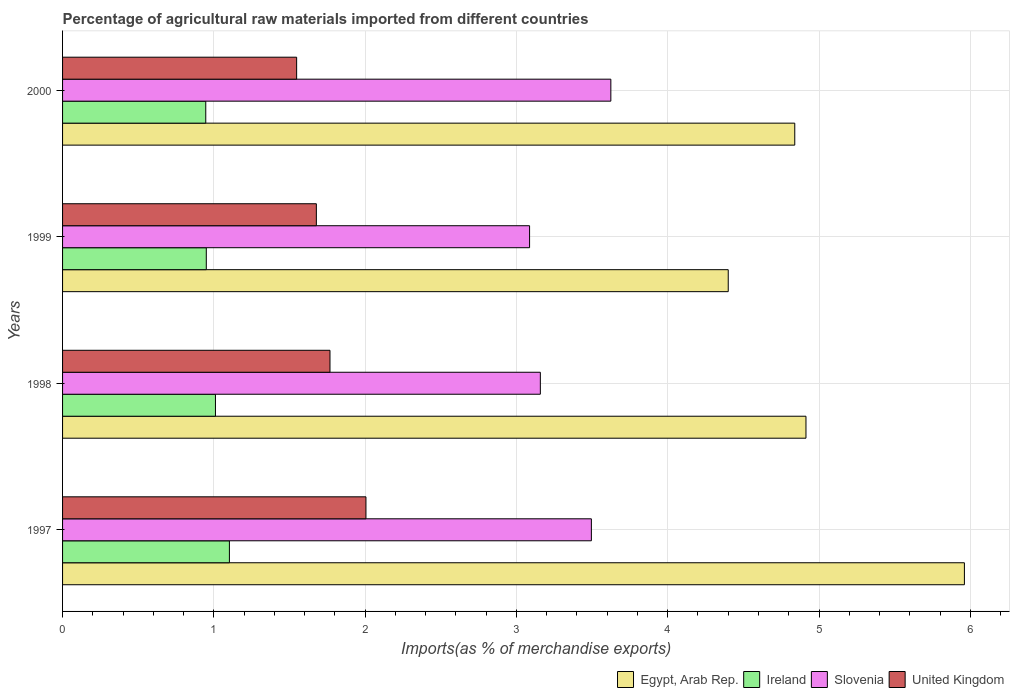How many groups of bars are there?
Keep it short and to the point. 4. How many bars are there on the 1st tick from the top?
Offer a very short reply. 4. What is the percentage of imports to different countries in Slovenia in 1998?
Your response must be concise. 3.16. Across all years, what is the maximum percentage of imports to different countries in Ireland?
Keep it short and to the point. 1.1. Across all years, what is the minimum percentage of imports to different countries in Slovenia?
Keep it short and to the point. 3.09. In which year was the percentage of imports to different countries in Egypt, Arab Rep. maximum?
Give a very brief answer. 1997. What is the total percentage of imports to different countries in Ireland in the graph?
Your response must be concise. 4.01. What is the difference between the percentage of imports to different countries in United Kingdom in 1997 and that in 1998?
Provide a short and direct response. 0.24. What is the difference between the percentage of imports to different countries in Egypt, Arab Rep. in 1997 and the percentage of imports to different countries in Ireland in 1998?
Offer a very short reply. 4.95. What is the average percentage of imports to different countries in Ireland per year?
Your answer should be compact. 1. In the year 1999, what is the difference between the percentage of imports to different countries in Slovenia and percentage of imports to different countries in United Kingdom?
Your response must be concise. 1.41. What is the ratio of the percentage of imports to different countries in Slovenia in 1997 to that in 1999?
Give a very brief answer. 1.13. What is the difference between the highest and the second highest percentage of imports to different countries in Ireland?
Your answer should be very brief. 0.09. What is the difference between the highest and the lowest percentage of imports to different countries in United Kingdom?
Your response must be concise. 0.46. In how many years, is the percentage of imports to different countries in Slovenia greater than the average percentage of imports to different countries in Slovenia taken over all years?
Give a very brief answer. 2. Is the sum of the percentage of imports to different countries in Ireland in 1997 and 1998 greater than the maximum percentage of imports to different countries in Slovenia across all years?
Make the answer very short. No. What does the 2nd bar from the top in 1998 represents?
Your answer should be compact. Slovenia. Is it the case that in every year, the sum of the percentage of imports to different countries in Slovenia and percentage of imports to different countries in Ireland is greater than the percentage of imports to different countries in Egypt, Arab Rep.?
Offer a very short reply. No. How many bars are there?
Offer a very short reply. 16. Are the values on the major ticks of X-axis written in scientific E-notation?
Provide a short and direct response. No. Does the graph contain any zero values?
Offer a terse response. No. Does the graph contain grids?
Keep it short and to the point. Yes. How many legend labels are there?
Offer a very short reply. 4. What is the title of the graph?
Keep it short and to the point. Percentage of agricultural raw materials imported from different countries. What is the label or title of the X-axis?
Make the answer very short. Imports(as % of merchandise exports). What is the Imports(as % of merchandise exports) of Egypt, Arab Rep. in 1997?
Provide a succinct answer. 5.96. What is the Imports(as % of merchandise exports) of Ireland in 1997?
Give a very brief answer. 1.1. What is the Imports(as % of merchandise exports) in Slovenia in 1997?
Offer a very short reply. 3.5. What is the Imports(as % of merchandise exports) in United Kingdom in 1997?
Make the answer very short. 2.01. What is the Imports(as % of merchandise exports) in Egypt, Arab Rep. in 1998?
Ensure brevity in your answer.  4.91. What is the Imports(as % of merchandise exports) of Ireland in 1998?
Your answer should be compact. 1.01. What is the Imports(as % of merchandise exports) in Slovenia in 1998?
Make the answer very short. 3.16. What is the Imports(as % of merchandise exports) in United Kingdom in 1998?
Offer a terse response. 1.77. What is the Imports(as % of merchandise exports) of Egypt, Arab Rep. in 1999?
Make the answer very short. 4.4. What is the Imports(as % of merchandise exports) in Ireland in 1999?
Offer a very short reply. 0.95. What is the Imports(as % of merchandise exports) of Slovenia in 1999?
Make the answer very short. 3.09. What is the Imports(as % of merchandise exports) of United Kingdom in 1999?
Your response must be concise. 1.68. What is the Imports(as % of merchandise exports) of Egypt, Arab Rep. in 2000?
Give a very brief answer. 4.84. What is the Imports(as % of merchandise exports) in Ireland in 2000?
Your answer should be very brief. 0.95. What is the Imports(as % of merchandise exports) of Slovenia in 2000?
Offer a very short reply. 3.62. What is the Imports(as % of merchandise exports) of United Kingdom in 2000?
Offer a terse response. 1.55. Across all years, what is the maximum Imports(as % of merchandise exports) in Egypt, Arab Rep.?
Give a very brief answer. 5.96. Across all years, what is the maximum Imports(as % of merchandise exports) of Ireland?
Your answer should be compact. 1.1. Across all years, what is the maximum Imports(as % of merchandise exports) of Slovenia?
Give a very brief answer. 3.62. Across all years, what is the maximum Imports(as % of merchandise exports) of United Kingdom?
Provide a short and direct response. 2.01. Across all years, what is the minimum Imports(as % of merchandise exports) of Egypt, Arab Rep.?
Your response must be concise. 4.4. Across all years, what is the minimum Imports(as % of merchandise exports) of Ireland?
Your response must be concise. 0.95. Across all years, what is the minimum Imports(as % of merchandise exports) of Slovenia?
Your answer should be compact. 3.09. Across all years, what is the minimum Imports(as % of merchandise exports) in United Kingdom?
Keep it short and to the point. 1.55. What is the total Imports(as % of merchandise exports) in Egypt, Arab Rep. in the graph?
Your response must be concise. 20.11. What is the total Imports(as % of merchandise exports) of Ireland in the graph?
Your answer should be compact. 4.01. What is the total Imports(as % of merchandise exports) in Slovenia in the graph?
Provide a short and direct response. 13.36. What is the total Imports(as % of merchandise exports) in United Kingdom in the graph?
Provide a short and direct response. 7. What is the difference between the Imports(as % of merchandise exports) in Egypt, Arab Rep. in 1997 and that in 1998?
Offer a very short reply. 1.05. What is the difference between the Imports(as % of merchandise exports) of Ireland in 1997 and that in 1998?
Keep it short and to the point. 0.09. What is the difference between the Imports(as % of merchandise exports) of Slovenia in 1997 and that in 1998?
Offer a terse response. 0.34. What is the difference between the Imports(as % of merchandise exports) in United Kingdom in 1997 and that in 1998?
Offer a terse response. 0.24. What is the difference between the Imports(as % of merchandise exports) in Egypt, Arab Rep. in 1997 and that in 1999?
Offer a terse response. 1.56. What is the difference between the Imports(as % of merchandise exports) in Ireland in 1997 and that in 1999?
Ensure brevity in your answer.  0.15. What is the difference between the Imports(as % of merchandise exports) of Slovenia in 1997 and that in 1999?
Offer a very short reply. 0.41. What is the difference between the Imports(as % of merchandise exports) of United Kingdom in 1997 and that in 1999?
Your response must be concise. 0.33. What is the difference between the Imports(as % of merchandise exports) of Egypt, Arab Rep. in 1997 and that in 2000?
Your answer should be very brief. 1.12. What is the difference between the Imports(as % of merchandise exports) in Ireland in 1997 and that in 2000?
Your answer should be very brief. 0.16. What is the difference between the Imports(as % of merchandise exports) of Slovenia in 1997 and that in 2000?
Your answer should be very brief. -0.13. What is the difference between the Imports(as % of merchandise exports) of United Kingdom in 1997 and that in 2000?
Your response must be concise. 0.46. What is the difference between the Imports(as % of merchandise exports) of Egypt, Arab Rep. in 1998 and that in 1999?
Make the answer very short. 0.51. What is the difference between the Imports(as % of merchandise exports) in Ireland in 1998 and that in 1999?
Your answer should be compact. 0.06. What is the difference between the Imports(as % of merchandise exports) in Slovenia in 1998 and that in 1999?
Your answer should be very brief. 0.07. What is the difference between the Imports(as % of merchandise exports) in United Kingdom in 1998 and that in 1999?
Make the answer very short. 0.09. What is the difference between the Imports(as % of merchandise exports) of Egypt, Arab Rep. in 1998 and that in 2000?
Provide a succinct answer. 0.07. What is the difference between the Imports(as % of merchandise exports) in Ireland in 1998 and that in 2000?
Your answer should be compact. 0.06. What is the difference between the Imports(as % of merchandise exports) of Slovenia in 1998 and that in 2000?
Your answer should be very brief. -0.47. What is the difference between the Imports(as % of merchandise exports) of United Kingdom in 1998 and that in 2000?
Offer a terse response. 0.22. What is the difference between the Imports(as % of merchandise exports) in Egypt, Arab Rep. in 1999 and that in 2000?
Your answer should be compact. -0.44. What is the difference between the Imports(as % of merchandise exports) of Ireland in 1999 and that in 2000?
Provide a succinct answer. 0. What is the difference between the Imports(as % of merchandise exports) of Slovenia in 1999 and that in 2000?
Keep it short and to the point. -0.54. What is the difference between the Imports(as % of merchandise exports) of United Kingdom in 1999 and that in 2000?
Your response must be concise. 0.13. What is the difference between the Imports(as % of merchandise exports) in Egypt, Arab Rep. in 1997 and the Imports(as % of merchandise exports) in Ireland in 1998?
Offer a very short reply. 4.95. What is the difference between the Imports(as % of merchandise exports) of Egypt, Arab Rep. in 1997 and the Imports(as % of merchandise exports) of Slovenia in 1998?
Offer a terse response. 2.8. What is the difference between the Imports(as % of merchandise exports) in Egypt, Arab Rep. in 1997 and the Imports(as % of merchandise exports) in United Kingdom in 1998?
Your answer should be compact. 4.19. What is the difference between the Imports(as % of merchandise exports) in Ireland in 1997 and the Imports(as % of merchandise exports) in Slovenia in 1998?
Provide a succinct answer. -2.06. What is the difference between the Imports(as % of merchandise exports) in Ireland in 1997 and the Imports(as % of merchandise exports) in United Kingdom in 1998?
Offer a terse response. -0.66. What is the difference between the Imports(as % of merchandise exports) of Slovenia in 1997 and the Imports(as % of merchandise exports) of United Kingdom in 1998?
Your answer should be very brief. 1.73. What is the difference between the Imports(as % of merchandise exports) of Egypt, Arab Rep. in 1997 and the Imports(as % of merchandise exports) of Ireland in 1999?
Your answer should be very brief. 5.01. What is the difference between the Imports(as % of merchandise exports) of Egypt, Arab Rep. in 1997 and the Imports(as % of merchandise exports) of Slovenia in 1999?
Make the answer very short. 2.87. What is the difference between the Imports(as % of merchandise exports) in Egypt, Arab Rep. in 1997 and the Imports(as % of merchandise exports) in United Kingdom in 1999?
Give a very brief answer. 4.28. What is the difference between the Imports(as % of merchandise exports) in Ireland in 1997 and the Imports(as % of merchandise exports) in Slovenia in 1999?
Provide a succinct answer. -1.98. What is the difference between the Imports(as % of merchandise exports) in Ireland in 1997 and the Imports(as % of merchandise exports) in United Kingdom in 1999?
Provide a succinct answer. -0.57. What is the difference between the Imports(as % of merchandise exports) of Slovenia in 1997 and the Imports(as % of merchandise exports) of United Kingdom in 1999?
Your answer should be compact. 1.82. What is the difference between the Imports(as % of merchandise exports) of Egypt, Arab Rep. in 1997 and the Imports(as % of merchandise exports) of Ireland in 2000?
Offer a very short reply. 5.01. What is the difference between the Imports(as % of merchandise exports) of Egypt, Arab Rep. in 1997 and the Imports(as % of merchandise exports) of Slovenia in 2000?
Your answer should be very brief. 2.34. What is the difference between the Imports(as % of merchandise exports) of Egypt, Arab Rep. in 1997 and the Imports(as % of merchandise exports) of United Kingdom in 2000?
Provide a short and direct response. 4.41. What is the difference between the Imports(as % of merchandise exports) in Ireland in 1997 and the Imports(as % of merchandise exports) in Slovenia in 2000?
Offer a terse response. -2.52. What is the difference between the Imports(as % of merchandise exports) in Ireland in 1997 and the Imports(as % of merchandise exports) in United Kingdom in 2000?
Your response must be concise. -0.44. What is the difference between the Imports(as % of merchandise exports) in Slovenia in 1997 and the Imports(as % of merchandise exports) in United Kingdom in 2000?
Your answer should be very brief. 1.95. What is the difference between the Imports(as % of merchandise exports) of Egypt, Arab Rep. in 1998 and the Imports(as % of merchandise exports) of Ireland in 1999?
Your response must be concise. 3.96. What is the difference between the Imports(as % of merchandise exports) of Egypt, Arab Rep. in 1998 and the Imports(as % of merchandise exports) of Slovenia in 1999?
Give a very brief answer. 1.83. What is the difference between the Imports(as % of merchandise exports) in Egypt, Arab Rep. in 1998 and the Imports(as % of merchandise exports) in United Kingdom in 1999?
Keep it short and to the point. 3.24. What is the difference between the Imports(as % of merchandise exports) in Ireland in 1998 and the Imports(as % of merchandise exports) in Slovenia in 1999?
Offer a terse response. -2.08. What is the difference between the Imports(as % of merchandise exports) in Ireland in 1998 and the Imports(as % of merchandise exports) in United Kingdom in 1999?
Your answer should be compact. -0.67. What is the difference between the Imports(as % of merchandise exports) of Slovenia in 1998 and the Imports(as % of merchandise exports) of United Kingdom in 1999?
Ensure brevity in your answer.  1.48. What is the difference between the Imports(as % of merchandise exports) of Egypt, Arab Rep. in 1998 and the Imports(as % of merchandise exports) of Ireland in 2000?
Offer a very short reply. 3.97. What is the difference between the Imports(as % of merchandise exports) in Egypt, Arab Rep. in 1998 and the Imports(as % of merchandise exports) in Slovenia in 2000?
Make the answer very short. 1.29. What is the difference between the Imports(as % of merchandise exports) in Egypt, Arab Rep. in 1998 and the Imports(as % of merchandise exports) in United Kingdom in 2000?
Keep it short and to the point. 3.37. What is the difference between the Imports(as % of merchandise exports) in Ireland in 1998 and the Imports(as % of merchandise exports) in Slovenia in 2000?
Your answer should be very brief. -2.61. What is the difference between the Imports(as % of merchandise exports) in Ireland in 1998 and the Imports(as % of merchandise exports) in United Kingdom in 2000?
Give a very brief answer. -0.54. What is the difference between the Imports(as % of merchandise exports) in Slovenia in 1998 and the Imports(as % of merchandise exports) in United Kingdom in 2000?
Give a very brief answer. 1.61. What is the difference between the Imports(as % of merchandise exports) in Egypt, Arab Rep. in 1999 and the Imports(as % of merchandise exports) in Ireland in 2000?
Provide a short and direct response. 3.45. What is the difference between the Imports(as % of merchandise exports) in Egypt, Arab Rep. in 1999 and the Imports(as % of merchandise exports) in Slovenia in 2000?
Make the answer very short. 0.78. What is the difference between the Imports(as % of merchandise exports) in Egypt, Arab Rep. in 1999 and the Imports(as % of merchandise exports) in United Kingdom in 2000?
Keep it short and to the point. 2.85. What is the difference between the Imports(as % of merchandise exports) in Ireland in 1999 and the Imports(as % of merchandise exports) in Slovenia in 2000?
Offer a very short reply. -2.67. What is the difference between the Imports(as % of merchandise exports) of Ireland in 1999 and the Imports(as % of merchandise exports) of United Kingdom in 2000?
Your answer should be very brief. -0.6. What is the difference between the Imports(as % of merchandise exports) in Slovenia in 1999 and the Imports(as % of merchandise exports) in United Kingdom in 2000?
Provide a succinct answer. 1.54. What is the average Imports(as % of merchandise exports) of Egypt, Arab Rep. per year?
Provide a succinct answer. 5.03. What is the average Imports(as % of merchandise exports) in Slovenia per year?
Keep it short and to the point. 3.34. What is the average Imports(as % of merchandise exports) in United Kingdom per year?
Give a very brief answer. 1.75. In the year 1997, what is the difference between the Imports(as % of merchandise exports) in Egypt, Arab Rep. and Imports(as % of merchandise exports) in Ireland?
Your answer should be very brief. 4.86. In the year 1997, what is the difference between the Imports(as % of merchandise exports) of Egypt, Arab Rep. and Imports(as % of merchandise exports) of Slovenia?
Your answer should be very brief. 2.47. In the year 1997, what is the difference between the Imports(as % of merchandise exports) of Egypt, Arab Rep. and Imports(as % of merchandise exports) of United Kingdom?
Your answer should be compact. 3.96. In the year 1997, what is the difference between the Imports(as % of merchandise exports) of Ireland and Imports(as % of merchandise exports) of Slovenia?
Give a very brief answer. -2.39. In the year 1997, what is the difference between the Imports(as % of merchandise exports) in Ireland and Imports(as % of merchandise exports) in United Kingdom?
Your answer should be very brief. -0.9. In the year 1997, what is the difference between the Imports(as % of merchandise exports) in Slovenia and Imports(as % of merchandise exports) in United Kingdom?
Your answer should be compact. 1.49. In the year 1998, what is the difference between the Imports(as % of merchandise exports) of Egypt, Arab Rep. and Imports(as % of merchandise exports) of Ireland?
Your answer should be compact. 3.9. In the year 1998, what is the difference between the Imports(as % of merchandise exports) of Egypt, Arab Rep. and Imports(as % of merchandise exports) of Slovenia?
Keep it short and to the point. 1.76. In the year 1998, what is the difference between the Imports(as % of merchandise exports) of Egypt, Arab Rep. and Imports(as % of merchandise exports) of United Kingdom?
Provide a short and direct response. 3.15. In the year 1998, what is the difference between the Imports(as % of merchandise exports) in Ireland and Imports(as % of merchandise exports) in Slovenia?
Provide a short and direct response. -2.15. In the year 1998, what is the difference between the Imports(as % of merchandise exports) of Ireland and Imports(as % of merchandise exports) of United Kingdom?
Your response must be concise. -0.76. In the year 1998, what is the difference between the Imports(as % of merchandise exports) in Slovenia and Imports(as % of merchandise exports) in United Kingdom?
Offer a very short reply. 1.39. In the year 1999, what is the difference between the Imports(as % of merchandise exports) in Egypt, Arab Rep. and Imports(as % of merchandise exports) in Ireland?
Your answer should be very brief. 3.45. In the year 1999, what is the difference between the Imports(as % of merchandise exports) in Egypt, Arab Rep. and Imports(as % of merchandise exports) in Slovenia?
Provide a short and direct response. 1.31. In the year 1999, what is the difference between the Imports(as % of merchandise exports) in Egypt, Arab Rep. and Imports(as % of merchandise exports) in United Kingdom?
Give a very brief answer. 2.72. In the year 1999, what is the difference between the Imports(as % of merchandise exports) in Ireland and Imports(as % of merchandise exports) in Slovenia?
Offer a terse response. -2.14. In the year 1999, what is the difference between the Imports(as % of merchandise exports) in Ireland and Imports(as % of merchandise exports) in United Kingdom?
Keep it short and to the point. -0.73. In the year 1999, what is the difference between the Imports(as % of merchandise exports) of Slovenia and Imports(as % of merchandise exports) of United Kingdom?
Offer a very short reply. 1.41. In the year 2000, what is the difference between the Imports(as % of merchandise exports) of Egypt, Arab Rep. and Imports(as % of merchandise exports) of Ireland?
Offer a very short reply. 3.89. In the year 2000, what is the difference between the Imports(as % of merchandise exports) of Egypt, Arab Rep. and Imports(as % of merchandise exports) of Slovenia?
Make the answer very short. 1.22. In the year 2000, what is the difference between the Imports(as % of merchandise exports) in Egypt, Arab Rep. and Imports(as % of merchandise exports) in United Kingdom?
Offer a very short reply. 3.29. In the year 2000, what is the difference between the Imports(as % of merchandise exports) in Ireland and Imports(as % of merchandise exports) in Slovenia?
Keep it short and to the point. -2.68. In the year 2000, what is the difference between the Imports(as % of merchandise exports) in Ireland and Imports(as % of merchandise exports) in United Kingdom?
Offer a terse response. -0.6. In the year 2000, what is the difference between the Imports(as % of merchandise exports) of Slovenia and Imports(as % of merchandise exports) of United Kingdom?
Your answer should be very brief. 2.08. What is the ratio of the Imports(as % of merchandise exports) of Egypt, Arab Rep. in 1997 to that in 1998?
Provide a short and direct response. 1.21. What is the ratio of the Imports(as % of merchandise exports) of Ireland in 1997 to that in 1998?
Your response must be concise. 1.09. What is the ratio of the Imports(as % of merchandise exports) in Slovenia in 1997 to that in 1998?
Provide a short and direct response. 1.11. What is the ratio of the Imports(as % of merchandise exports) in United Kingdom in 1997 to that in 1998?
Your answer should be very brief. 1.13. What is the ratio of the Imports(as % of merchandise exports) in Egypt, Arab Rep. in 1997 to that in 1999?
Make the answer very short. 1.35. What is the ratio of the Imports(as % of merchandise exports) of Ireland in 1997 to that in 1999?
Ensure brevity in your answer.  1.16. What is the ratio of the Imports(as % of merchandise exports) in Slovenia in 1997 to that in 1999?
Your answer should be very brief. 1.13. What is the ratio of the Imports(as % of merchandise exports) of United Kingdom in 1997 to that in 1999?
Your answer should be compact. 1.2. What is the ratio of the Imports(as % of merchandise exports) in Egypt, Arab Rep. in 1997 to that in 2000?
Your answer should be compact. 1.23. What is the ratio of the Imports(as % of merchandise exports) in Ireland in 1997 to that in 2000?
Offer a terse response. 1.17. What is the ratio of the Imports(as % of merchandise exports) in Slovenia in 1997 to that in 2000?
Provide a succinct answer. 0.96. What is the ratio of the Imports(as % of merchandise exports) in United Kingdom in 1997 to that in 2000?
Ensure brevity in your answer.  1.3. What is the ratio of the Imports(as % of merchandise exports) of Egypt, Arab Rep. in 1998 to that in 1999?
Make the answer very short. 1.12. What is the ratio of the Imports(as % of merchandise exports) of Ireland in 1998 to that in 1999?
Keep it short and to the point. 1.06. What is the ratio of the Imports(as % of merchandise exports) in United Kingdom in 1998 to that in 1999?
Give a very brief answer. 1.05. What is the ratio of the Imports(as % of merchandise exports) in Egypt, Arab Rep. in 1998 to that in 2000?
Provide a succinct answer. 1.02. What is the ratio of the Imports(as % of merchandise exports) in Ireland in 1998 to that in 2000?
Keep it short and to the point. 1.07. What is the ratio of the Imports(as % of merchandise exports) in Slovenia in 1998 to that in 2000?
Your answer should be very brief. 0.87. What is the ratio of the Imports(as % of merchandise exports) of United Kingdom in 1998 to that in 2000?
Offer a very short reply. 1.14. What is the ratio of the Imports(as % of merchandise exports) in Egypt, Arab Rep. in 1999 to that in 2000?
Keep it short and to the point. 0.91. What is the ratio of the Imports(as % of merchandise exports) in Slovenia in 1999 to that in 2000?
Keep it short and to the point. 0.85. What is the ratio of the Imports(as % of merchandise exports) of United Kingdom in 1999 to that in 2000?
Offer a terse response. 1.08. What is the difference between the highest and the second highest Imports(as % of merchandise exports) of Egypt, Arab Rep.?
Make the answer very short. 1.05. What is the difference between the highest and the second highest Imports(as % of merchandise exports) in Ireland?
Provide a succinct answer. 0.09. What is the difference between the highest and the second highest Imports(as % of merchandise exports) of Slovenia?
Make the answer very short. 0.13. What is the difference between the highest and the second highest Imports(as % of merchandise exports) in United Kingdom?
Provide a short and direct response. 0.24. What is the difference between the highest and the lowest Imports(as % of merchandise exports) in Egypt, Arab Rep.?
Your answer should be compact. 1.56. What is the difference between the highest and the lowest Imports(as % of merchandise exports) of Ireland?
Make the answer very short. 0.16. What is the difference between the highest and the lowest Imports(as % of merchandise exports) in Slovenia?
Your answer should be compact. 0.54. What is the difference between the highest and the lowest Imports(as % of merchandise exports) in United Kingdom?
Keep it short and to the point. 0.46. 